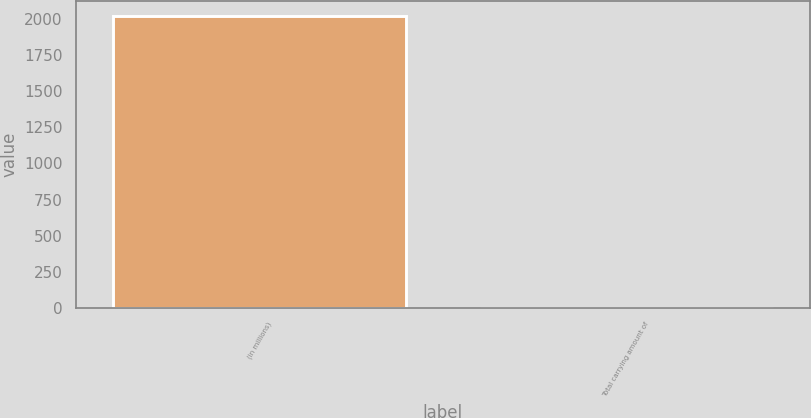<chart> <loc_0><loc_0><loc_500><loc_500><bar_chart><fcel>(in millions)<fcel>Total carrying amount of<nl><fcel>2019<fcel>2.7<nl></chart> 